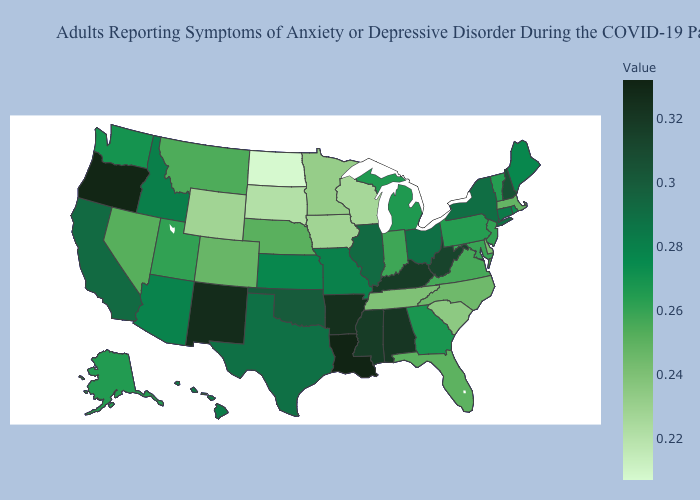Which states hav the highest value in the MidWest?
Concise answer only. Illinois. Does Illinois have the highest value in the MidWest?
Answer briefly. Yes. Does the map have missing data?
Short answer required. No. Among the states that border Kentucky , which have the highest value?
Quick response, please. West Virginia. Does California have the lowest value in the USA?
Write a very short answer. No. 